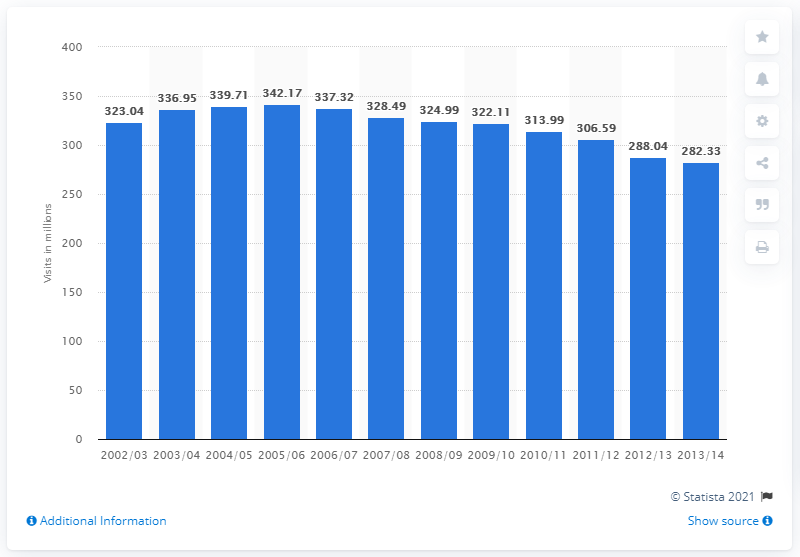Identify some key points in this picture. In the 2012/2013 fiscal year, a total of 288.04 library visits were made. In the 2013/14 academic year, a total of 282.33 library visits were made. 